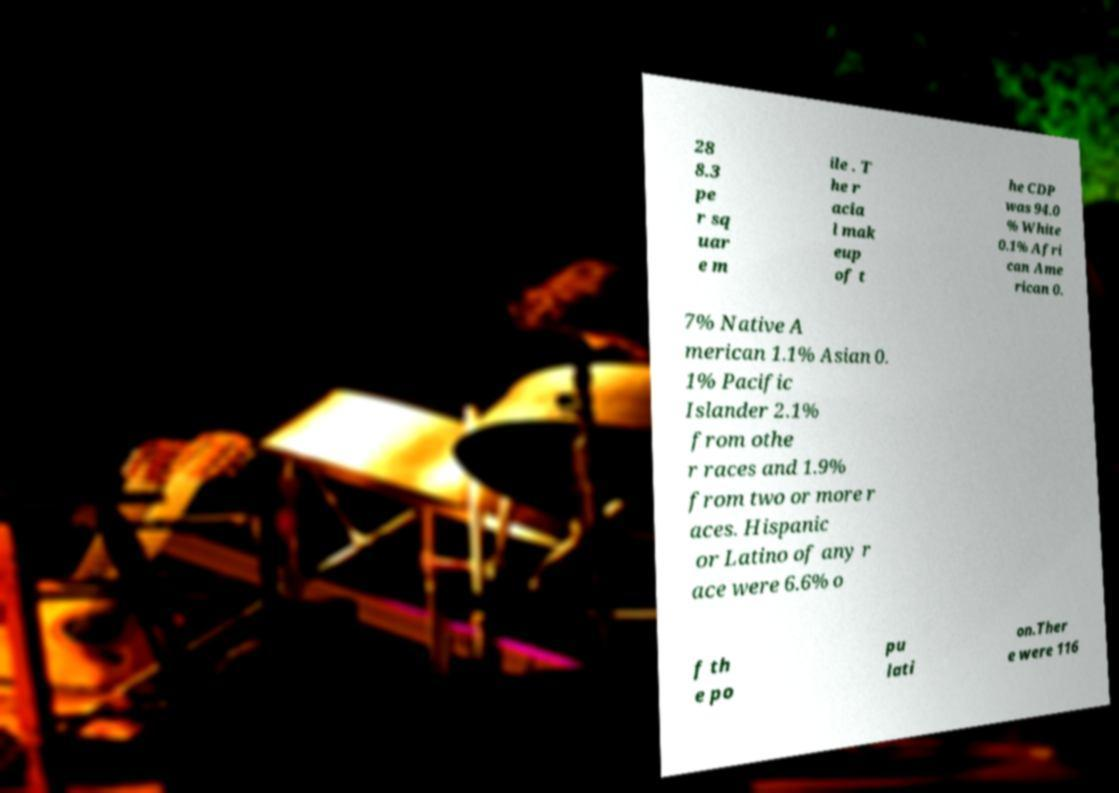For documentation purposes, I need the text within this image transcribed. Could you provide that? 28 8.3 pe r sq uar e m ile . T he r acia l mak eup of t he CDP was 94.0 % White 0.1% Afri can Ame rican 0. 7% Native A merican 1.1% Asian 0. 1% Pacific Islander 2.1% from othe r races and 1.9% from two or more r aces. Hispanic or Latino of any r ace were 6.6% o f th e po pu lati on.Ther e were 116 